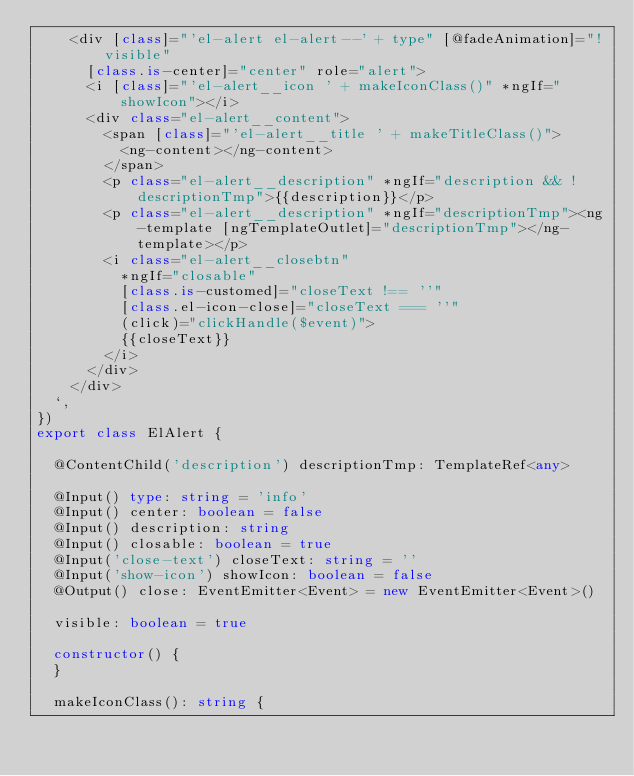Convert code to text. <code><loc_0><loc_0><loc_500><loc_500><_TypeScript_>    <div [class]="'el-alert el-alert--' + type" [@fadeAnimation]="!visible"
      [class.is-center]="center" role="alert">
      <i [class]="'el-alert__icon ' + makeIconClass()" *ngIf="showIcon"></i>
      <div class="el-alert__content">
        <span [class]="'el-alert__title ' + makeTitleClass()">
          <ng-content></ng-content>
        </span>
        <p class="el-alert__description" *ngIf="description && !descriptionTmp">{{description}}</p>
        <p class="el-alert__description" *ngIf="descriptionTmp"><ng-template [ngTemplateOutlet]="descriptionTmp"></ng-template></p>
        <i class="el-alert__closebtn"
          *ngIf="closable"
          [class.is-customed]="closeText !== ''"
          [class.el-icon-close]="closeText === ''"
          (click)="clickHandle($event)">
          {{closeText}}
        </i>
      </div>
    </div>
  `,
})
export class ElAlert {
  
  @ContentChild('description') descriptionTmp: TemplateRef<any>
  
  @Input() type: string = 'info'
  @Input() center: boolean = false
  @Input() description: string
  @Input() closable: boolean = true
  @Input('close-text') closeText: string = ''
  @Input('show-icon') showIcon: boolean = false
  @Output() close: EventEmitter<Event> = new EventEmitter<Event>()
  
  visible: boolean = true
  
  constructor() {
  }
  
  makeIconClass(): string {</code> 